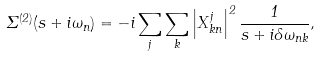<formula> <loc_0><loc_0><loc_500><loc_500>\Sigma ^ { ( 2 ) } ( s + i \omega _ { n } ) = - i \sum _ { j } \sum _ { k } \left | X _ { k n } ^ { j } \right | ^ { 2 } \frac { 1 } { s + i \delta \omega _ { n k } } ,</formula> 